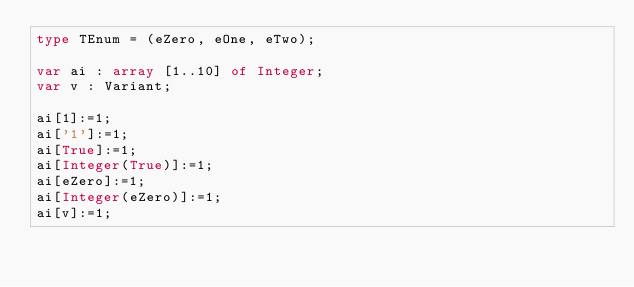Convert code to text. <code><loc_0><loc_0><loc_500><loc_500><_Pascal_>type TEnum = (eZero, eOne, eTwo);

var ai : array [1..10] of Integer;
var v : Variant;

ai[1]:=1;
ai['1']:=1;
ai[True]:=1;
ai[Integer(True)]:=1;
ai[eZero]:=1;
ai[Integer(eZero)]:=1;
ai[v]:=1;</code> 